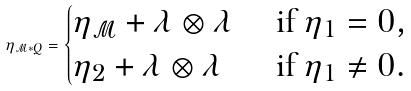<formula> <loc_0><loc_0><loc_500><loc_500>\eta _ { \mathcal { M } * Q } = \begin{cases} \eta _ { \mathcal { M } } + \lambda \otimes \lambda & \text { if } \eta _ { 1 } = 0 , \\ \eta _ { 2 } + \lambda \otimes \lambda & \text { if } \eta _ { 1 } \neq 0 . \end{cases}</formula> 